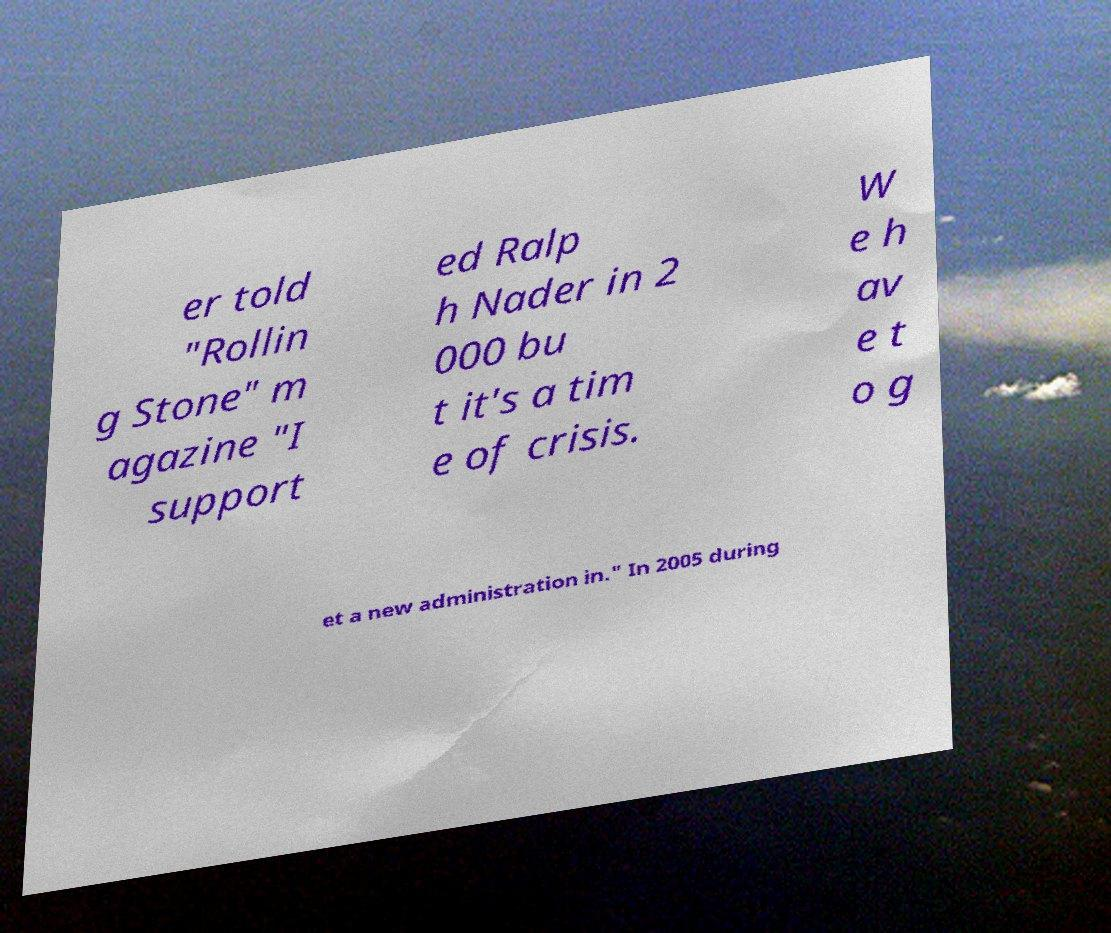Can you accurately transcribe the text from the provided image for me? er told "Rollin g Stone" m agazine "I support ed Ralp h Nader in 2 000 bu t it's a tim e of crisis. W e h av e t o g et a new administration in." In 2005 during 